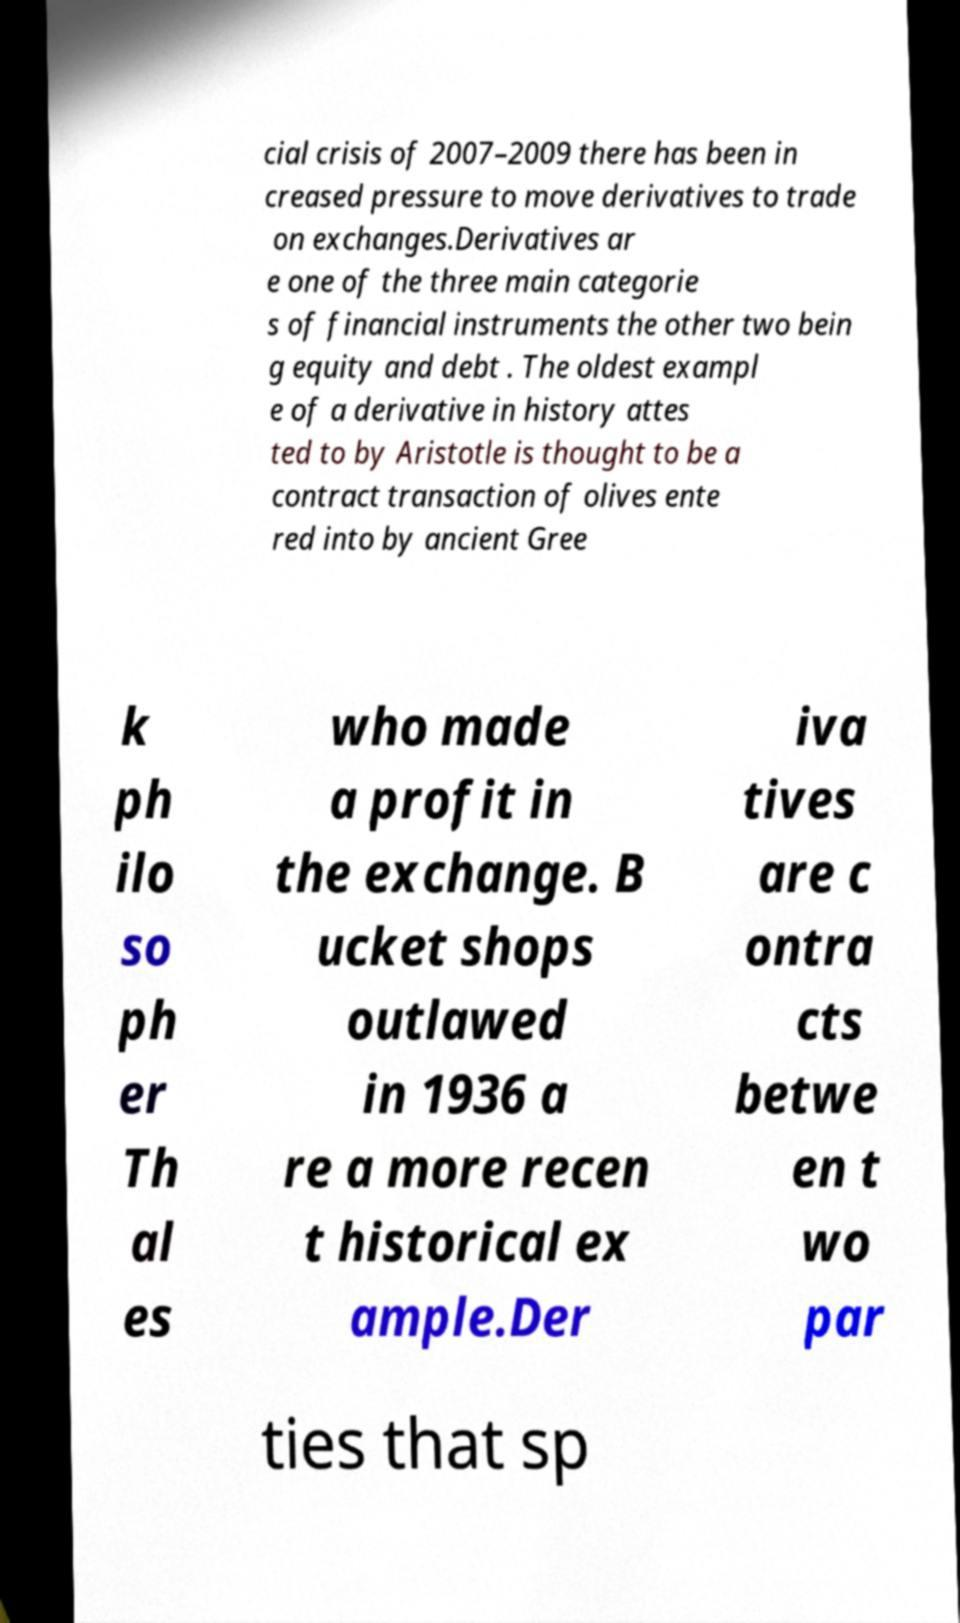Please read and relay the text visible in this image. What does it say? cial crisis of 2007–2009 there has been in creased pressure to move derivatives to trade on exchanges.Derivatives ar e one of the three main categorie s of financial instruments the other two bein g equity and debt . The oldest exampl e of a derivative in history attes ted to by Aristotle is thought to be a contract transaction of olives ente red into by ancient Gree k ph ilo so ph er Th al es who made a profit in the exchange. B ucket shops outlawed in 1936 a re a more recen t historical ex ample.Der iva tives are c ontra cts betwe en t wo par ties that sp 